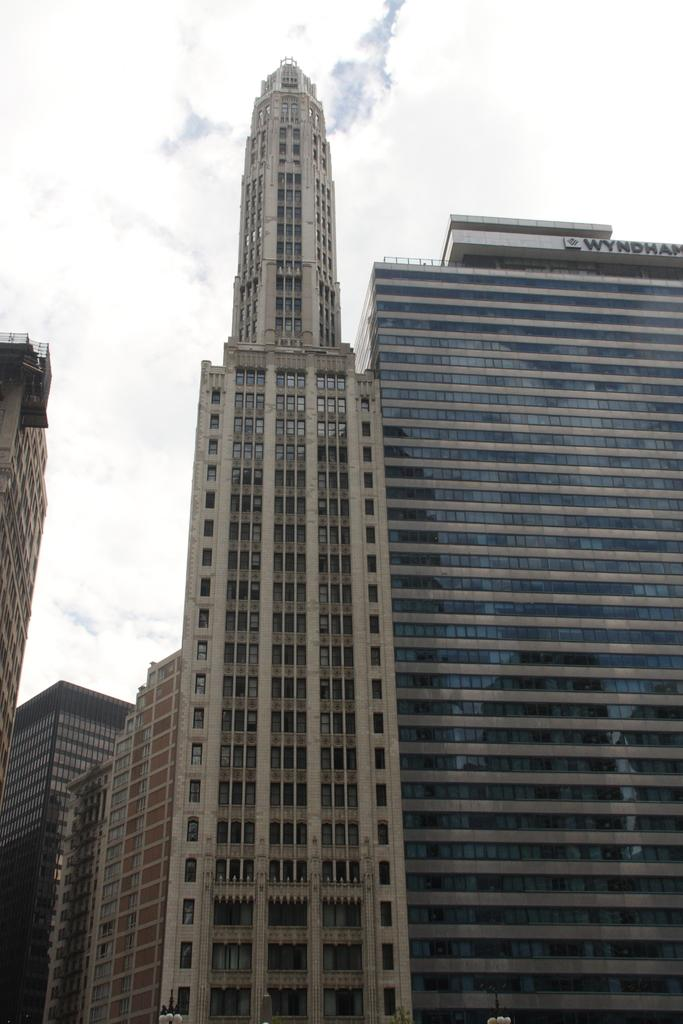What type of structures are visible in the image? There are high rise buildings in the image. Can you describe the height of the buildings? The buildings are described as high rise, which suggests they are tall and likely to be found in urban areas. What might be the purpose of these buildings? The purpose of these buildings could vary, but they are likely to be used for residential, commercial, or mixed purposes. What type of cord is being used in the event depicted in the image? There is no event or cord present in the image; it only features high rise buildings. 